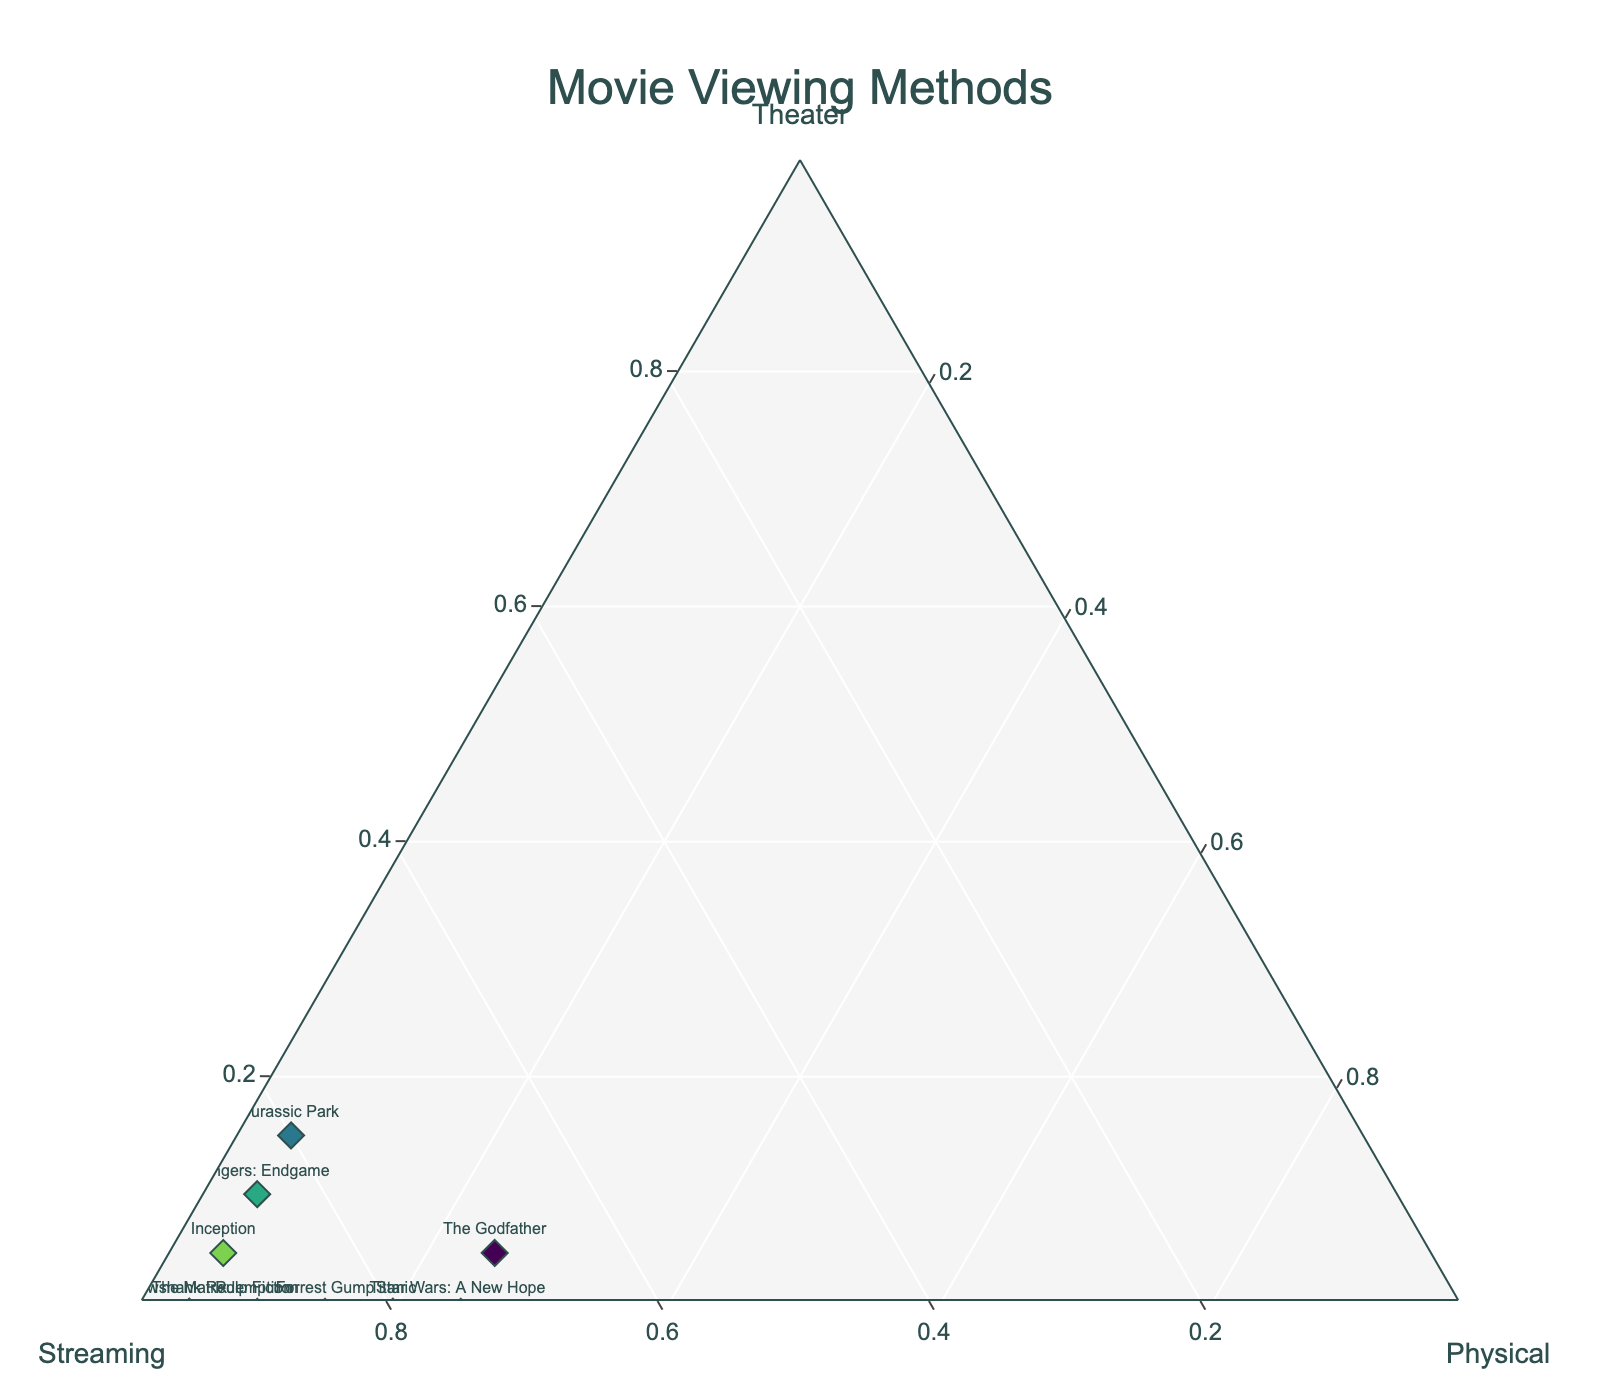what is the title of the plot? The title of the plot is typically displayed in a prominent position, often near the top of the figure. In this case, the centered and prominent text at the top indicates the title of the plot.
Answer: Movie Viewing Methods What are the labels of the three axes? Axes labels can generally be found at the ends or along the axes lines. In this plot, the labels are "Theater," "Streaming," and "Physical" as indicated near the edges of the triangle.
Answer: Theater, Streaming, Physical Which movie has the highest ratio of streaming views? You can determine the maximum value by examining the markers in the plot. The movie with the highest streaming ratio is marked with 95% and is closest to the "Streaming" axis.
Answer: The Matrix, The Shawshank Redemption Which movie has the least percentage of theater views? The movies with 0% in the Theater category are closest to the "Physical" and "Streaming" axis. Observing all points, movies such as "Pulp Fiction" and "Star Wars: A New Hope" have 0% theater views.
Answer: Pulp Fiction, Star Wars: A New Hope, The Matrix, Forrest Gump, The Shawshank Redemption, Titanic What is the ratio of streaming to physical views for "The Godfather"? The "Streaming" views and "Physical" views can be read directly from the data points for "The Godfather," which are annotated close to the plot's markers.
Answer: 70% Streaming, 25% Physical Which two movies have the same ratio of physical media views? Movies that share the same "Physical" percentage are marked along similar lines extending from that particular axis. Both "Star Wars: A New Hope" and "The Godfather" have identical ratios in physical media views.
Answer: Star Wars: A New Hope, The Godfather What is the difference between the streaming views for "Avengers: Endgame" and "Jurassic Park"? By comparing their positions and reading the value of the streaming percentage adjacent to each movie's marker, the difference can be calculated. "Avengers: Endgame" has 85% while "Jurassic Park" has 80%, making the difference 85% - 80%.
Answer: 5% What is the average percentage of theater views across all movies? Summing up theater percentages: (10 + 5 + 0 + 0 + 15 + 0 + 0 + 5 + 0 + 0) and then dividing by the number of movies (10). (35%) / 10 = 3.5%.
Answer: 3.5% Which movie is closest to having an equal distribution across all three viewing methods? The movie closest to the center of the ternary plot will have the most balanced ratios across all three categories. "The Godfather," with its ratios, seems closest to being evenly distributed.
Answer: The Godfather 